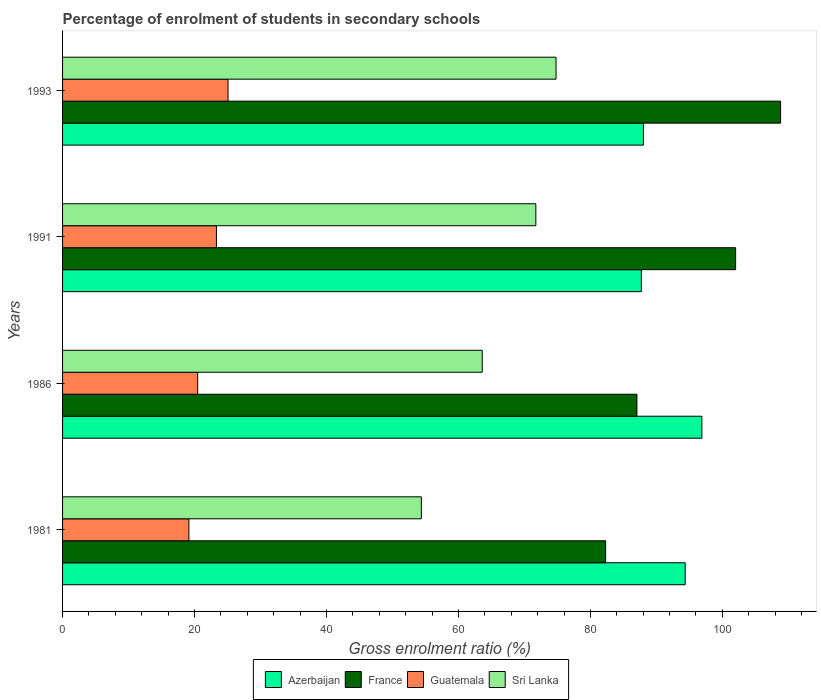Are the number of bars per tick equal to the number of legend labels?
Your answer should be compact. Yes. Are the number of bars on each tick of the Y-axis equal?
Keep it short and to the point. Yes. How many bars are there on the 1st tick from the bottom?
Keep it short and to the point. 4. In how many cases, is the number of bars for a given year not equal to the number of legend labels?
Your answer should be compact. 0. What is the percentage of students enrolled in secondary schools in Guatemala in 1986?
Provide a short and direct response. 20.48. Across all years, what is the maximum percentage of students enrolled in secondary schools in Azerbaijan?
Provide a succinct answer. 96.89. Across all years, what is the minimum percentage of students enrolled in secondary schools in France?
Provide a succinct answer. 82.31. In which year was the percentage of students enrolled in secondary schools in Azerbaijan maximum?
Offer a terse response. 1986. What is the total percentage of students enrolled in secondary schools in Sri Lanka in the graph?
Your answer should be compact. 264.51. What is the difference between the percentage of students enrolled in secondary schools in Azerbaijan in 1981 and that in 1993?
Ensure brevity in your answer.  6.33. What is the difference between the percentage of students enrolled in secondary schools in France in 1981 and the percentage of students enrolled in secondary schools in Sri Lanka in 1993?
Your answer should be compact. 7.51. What is the average percentage of students enrolled in secondary schools in Sri Lanka per year?
Keep it short and to the point. 66.13. In the year 1981, what is the difference between the percentage of students enrolled in secondary schools in Guatemala and percentage of students enrolled in secondary schools in Azerbaijan?
Offer a very short reply. -75.22. In how many years, is the percentage of students enrolled in secondary schools in France greater than 36 %?
Keep it short and to the point. 4. What is the ratio of the percentage of students enrolled in secondary schools in France in 1991 to that in 1993?
Provide a succinct answer. 0.94. What is the difference between the highest and the second highest percentage of students enrolled in secondary schools in Azerbaijan?
Your answer should be very brief. 2.53. What is the difference between the highest and the lowest percentage of students enrolled in secondary schools in Guatemala?
Make the answer very short. 5.93. In how many years, is the percentage of students enrolled in secondary schools in Sri Lanka greater than the average percentage of students enrolled in secondary schools in Sri Lanka taken over all years?
Your answer should be very brief. 2. Is the sum of the percentage of students enrolled in secondary schools in France in 1981 and 1993 greater than the maximum percentage of students enrolled in secondary schools in Guatemala across all years?
Give a very brief answer. Yes. What does the 4th bar from the top in 1981 represents?
Keep it short and to the point. Azerbaijan. What does the 4th bar from the bottom in 1993 represents?
Make the answer very short. Sri Lanka. Is it the case that in every year, the sum of the percentage of students enrolled in secondary schools in Guatemala and percentage of students enrolled in secondary schools in Azerbaijan is greater than the percentage of students enrolled in secondary schools in France?
Make the answer very short. Yes. How many bars are there?
Your answer should be compact. 16. What is the difference between two consecutive major ticks on the X-axis?
Ensure brevity in your answer.  20. Are the values on the major ticks of X-axis written in scientific E-notation?
Offer a very short reply. No. Where does the legend appear in the graph?
Offer a very short reply. Bottom center. How are the legend labels stacked?
Offer a terse response. Horizontal. What is the title of the graph?
Offer a terse response. Percentage of enrolment of students in secondary schools. Does "Central Europe" appear as one of the legend labels in the graph?
Offer a very short reply. No. What is the label or title of the X-axis?
Ensure brevity in your answer.  Gross enrolment ratio (%). What is the label or title of the Y-axis?
Offer a terse response. Years. What is the Gross enrolment ratio (%) of Azerbaijan in 1981?
Provide a succinct answer. 94.37. What is the Gross enrolment ratio (%) in France in 1981?
Provide a short and direct response. 82.31. What is the Gross enrolment ratio (%) of Guatemala in 1981?
Your response must be concise. 19.15. What is the Gross enrolment ratio (%) in Sri Lanka in 1981?
Your answer should be compact. 54.38. What is the Gross enrolment ratio (%) of Azerbaijan in 1986?
Provide a succinct answer. 96.89. What is the Gross enrolment ratio (%) of France in 1986?
Offer a very short reply. 87.05. What is the Gross enrolment ratio (%) of Guatemala in 1986?
Give a very brief answer. 20.48. What is the Gross enrolment ratio (%) in Sri Lanka in 1986?
Offer a very short reply. 63.61. What is the Gross enrolment ratio (%) in Azerbaijan in 1991?
Offer a terse response. 87.72. What is the Gross enrolment ratio (%) of France in 1991?
Ensure brevity in your answer.  102.01. What is the Gross enrolment ratio (%) of Guatemala in 1991?
Ensure brevity in your answer.  23.32. What is the Gross enrolment ratio (%) in Sri Lanka in 1991?
Your answer should be very brief. 71.73. What is the Gross enrolment ratio (%) of Azerbaijan in 1993?
Provide a short and direct response. 88.04. What is the Gross enrolment ratio (%) of France in 1993?
Provide a short and direct response. 108.82. What is the Gross enrolment ratio (%) in Guatemala in 1993?
Your response must be concise. 25.08. What is the Gross enrolment ratio (%) in Sri Lanka in 1993?
Your answer should be very brief. 74.79. Across all years, what is the maximum Gross enrolment ratio (%) of Azerbaijan?
Ensure brevity in your answer.  96.89. Across all years, what is the maximum Gross enrolment ratio (%) of France?
Your response must be concise. 108.82. Across all years, what is the maximum Gross enrolment ratio (%) of Guatemala?
Offer a very short reply. 25.08. Across all years, what is the maximum Gross enrolment ratio (%) of Sri Lanka?
Ensure brevity in your answer.  74.79. Across all years, what is the minimum Gross enrolment ratio (%) of Azerbaijan?
Make the answer very short. 87.72. Across all years, what is the minimum Gross enrolment ratio (%) in France?
Your answer should be compact. 82.31. Across all years, what is the minimum Gross enrolment ratio (%) in Guatemala?
Provide a short and direct response. 19.15. Across all years, what is the minimum Gross enrolment ratio (%) in Sri Lanka?
Give a very brief answer. 54.38. What is the total Gross enrolment ratio (%) of Azerbaijan in the graph?
Offer a terse response. 367.01. What is the total Gross enrolment ratio (%) in France in the graph?
Your answer should be compact. 380.19. What is the total Gross enrolment ratio (%) in Guatemala in the graph?
Ensure brevity in your answer.  88.02. What is the total Gross enrolment ratio (%) in Sri Lanka in the graph?
Provide a short and direct response. 264.51. What is the difference between the Gross enrolment ratio (%) of Azerbaijan in 1981 and that in 1986?
Give a very brief answer. -2.53. What is the difference between the Gross enrolment ratio (%) in France in 1981 and that in 1986?
Offer a very short reply. -4.74. What is the difference between the Gross enrolment ratio (%) in Guatemala in 1981 and that in 1986?
Offer a very short reply. -1.33. What is the difference between the Gross enrolment ratio (%) of Sri Lanka in 1981 and that in 1986?
Provide a succinct answer. -9.23. What is the difference between the Gross enrolment ratio (%) of Azerbaijan in 1981 and that in 1991?
Your response must be concise. 6.65. What is the difference between the Gross enrolment ratio (%) of France in 1981 and that in 1991?
Ensure brevity in your answer.  -19.7. What is the difference between the Gross enrolment ratio (%) of Guatemala in 1981 and that in 1991?
Your response must be concise. -4.17. What is the difference between the Gross enrolment ratio (%) in Sri Lanka in 1981 and that in 1991?
Make the answer very short. -17.35. What is the difference between the Gross enrolment ratio (%) in Azerbaijan in 1981 and that in 1993?
Make the answer very short. 6.33. What is the difference between the Gross enrolment ratio (%) of France in 1981 and that in 1993?
Keep it short and to the point. -26.52. What is the difference between the Gross enrolment ratio (%) in Guatemala in 1981 and that in 1993?
Offer a terse response. -5.93. What is the difference between the Gross enrolment ratio (%) of Sri Lanka in 1981 and that in 1993?
Your answer should be very brief. -20.42. What is the difference between the Gross enrolment ratio (%) in Azerbaijan in 1986 and that in 1991?
Keep it short and to the point. 9.17. What is the difference between the Gross enrolment ratio (%) of France in 1986 and that in 1991?
Your answer should be very brief. -14.96. What is the difference between the Gross enrolment ratio (%) of Guatemala in 1986 and that in 1991?
Provide a succinct answer. -2.84. What is the difference between the Gross enrolment ratio (%) in Sri Lanka in 1986 and that in 1991?
Give a very brief answer. -8.12. What is the difference between the Gross enrolment ratio (%) in Azerbaijan in 1986 and that in 1993?
Your response must be concise. 8.86. What is the difference between the Gross enrolment ratio (%) of France in 1986 and that in 1993?
Offer a terse response. -21.77. What is the difference between the Gross enrolment ratio (%) in Guatemala in 1986 and that in 1993?
Keep it short and to the point. -4.6. What is the difference between the Gross enrolment ratio (%) of Sri Lanka in 1986 and that in 1993?
Provide a short and direct response. -11.19. What is the difference between the Gross enrolment ratio (%) of Azerbaijan in 1991 and that in 1993?
Your answer should be very brief. -0.32. What is the difference between the Gross enrolment ratio (%) in France in 1991 and that in 1993?
Provide a succinct answer. -6.82. What is the difference between the Gross enrolment ratio (%) of Guatemala in 1991 and that in 1993?
Your answer should be very brief. -1.76. What is the difference between the Gross enrolment ratio (%) in Sri Lanka in 1991 and that in 1993?
Keep it short and to the point. -3.06. What is the difference between the Gross enrolment ratio (%) in Azerbaijan in 1981 and the Gross enrolment ratio (%) in France in 1986?
Ensure brevity in your answer.  7.31. What is the difference between the Gross enrolment ratio (%) in Azerbaijan in 1981 and the Gross enrolment ratio (%) in Guatemala in 1986?
Offer a terse response. 73.89. What is the difference between the Gross enrolment ratio (%) in Azerbaijan in 1981 and the Gross enrolment ratio (%) in Sri Lanka in 1986?
Keep it short and to the point. 30.76. What is the difference between the Gross enrolment ratio (%) of France in 1981 and the Gross enrolment ratio (%) of Guatemala in 1986?
Keep it short and to the point. 61.83. What is the difference between the Gross enrolment ratio (%) in France in 1981 and the Gross enrolment ratio (%) in Sri Lanka in 1986?
Your answer should be very brief. 18.7. What is the difference between the Gross enrolment ratio (%) in Guatemala in 1981 and the Gross enrolment ratio (%) in Sri Lanka in 1986?
Make the answer very short. -44.46. What is the difference between the Gross enrolment ratio (%) of Azerbaijan in 1981 and the Gross enrolment ratio (%) of France in 1991?
Make the answer very short. -7.64. What is the difference between the Gross enrolment ratio (%) in Azerbaijan in 1981 and the Gross enrolment ratio (%) in Guatemala in 1991?
Your answer should be compact. 71.04. What is the difference between the Gross enrolment ratio (%) in Azerbaijan in 1981 and the Gross enrolment ratio (%) in Sri Lanka in 1991?
Provide a short and direct response. 22.64. What is the difference between the Gross enrolment ratio (%) of France in 1981 and the Gross enrolment ratio (%) of Guatemala in 1991?
Your answer should be very brief. 58.99. What is the difference between the Gross enrolment ratio (%) in France in 1981 and the Gross enrolment ratio (%) in Sri Lanka in 1991?
Make the answer very short. 10.58. What is the difference between the Gross enrolment ratio (%) of Guatemala in 1981 and the Gross enrolment ratio (%) of Sri Lanka in 1991?
Make the answer very short. -52.58. What is the difference between the Gross enrolment ratio (%) of Azerbaijan in 1981 and the Gross enrolment ratio (%) of France in 1993?
Offer a very short reply. -14.46. What is the difference between the Gross enrolment ratio (%) of Azerbaijan in 1981 and the Gross enrolment ratio (%) of Guatemala in 1993?
Offer a very short reply. 69.29. What is the difference between the Gross enrolment ratio (%) of Azerbaijan in 1981 and the Gross enrolment ratio (%) of Sri Lanka in 1993?
Offer a terse response. 19.57. What is the difference between the Gross enrolment ratio (%) in France in 1981 and the Gross enrolment ratio (%) in Guatemala in 1993?
Provide a succinct answer. 57.23. What is the difference between the Gross enrolment ratio (%) in France in 1981 and the Gross enrolment ratio (%) in Sri Lanka in 1993?
Make the answer very short. 7.51. What is the difference between the Gross enrolment ratio (%) in Guatemala in 1981 and the Gross enrolment ratio (%) in Sri Lanka in 1993?
Offer a very short reply. -55.65. What is the difference between the Gross enrolment ratio (%) in Azerbaijan in 1986 and the Gross enrolment ratio (%) in France in 1991?
Your answer should be very brief. -5.12. What is the difference between the Gross enrolment ratio (%) in Azerbaijan in 1986 and the Gross enrolment ratio (%) in Guatemala in 1991?
Offer a very short reply. 73.57. What is the difference between the Gross enrolment ratio (%) in Azerbaijan in 1986 and the Gross enrolment ratio (%) in Sri Lanka in 1991?
Offer a very short reply. 25.16. What is the difference between the Gross enrolment ratio (%) of France in 1986 and the Gross enrolment ratio (%) of Guatemala in 1991?
Make the answer very short. 63.73. What is the difference between the Gross enrolment ratio (%) of France in 1986 and the Gross enrolment ratio (%) of Sri Lanka in 1991?
Make the answer very short. 15.32. What is the difference between the Gross enrolment ratio (%) in Guatemala in 1986 and the Gross enrolment ratio (%) in Sri Lanka in 1991?
Give a very brief answer. -51.25. What is the difference between the Gross enrolment ratio (%) in Azerbaijan in 1986 and the Gross enrolment ratio (%) in France in 1993?
Give a very brief answer. -11.93. What is the difference between the Gross enrolment ratio (%) of Azerbaijan in 1986 and the Gross enrolment ratio (%) of Guatemala in 1993?
Your response must be concise. 71.82. What is the difference between the Gross enrolment ratio (%) in Azerbaijan in 1986 and the Gross enrolment ratio (%) in Sri Lanka in 1993?
Offer a very short reply. 22.1. What is the difference between the Gross enrolment ratio (%) of France in 1986 and the Gross enrolment ratio (%) of Guatemala in 1993?
Your answer should be compact. 61.97. What is the difference between the Gross enrolment ratio (%) of France in 1986 and the Gross enrolment ratio (%) of Sri Lanka in 1993?
Provide a succinct answer. 12.26. What is the difference between the Gross enrolment ratio (%) in Guatemala in 1986 and the Gross enrolment ratio (%) in Sri Lanka in 1993?
Make the answer very short. -54.32. What is the difference between the Gross enrolment ratio (%) in Azerbaijan in 1991 and the Gross enrolment ratio (%) in France in 1993?
Give a very brief answer. -21.1. What is the difference between the Gross enrolment ratio (%) in Azerbaijan in 1991 and the Gross enrolment ratio (%) in Guatemala in 1993?
Give a very brief answer. 62.64. What is the difference between the Gross enrolment ratio (%) of Azerbaijan in 1991 and the Gross enrolment ratio (%) of Sri Lanka in 1993?
Ensure brevity in your answer.  12.93. What is the difference between the Gross enrolment ratio (%) in France in 1991 and the Gross enrolment ratio (%) in Guatemala in 1993?
Your answer should be very brief. 76.93. What is the difference between the Gross enrolment ratio (%) of France in 1991 and the Gross enrolment ratio (%) of Sri Lanka in 1993?
Provide a succinct answer. 27.21. What is the difference between the Gross enrolment ratio (%) of Guatemala in 1991 and the Gross enrolment ratio (%) of Sri Lanka in 1993?
Ensure brevity in your answer.  -51.47. What is the average Gross enrolment ratio (%) in Azerbaijan per year?
Offer a very short reply. 91.75. What is the average Gross enrolment ratio (%) of France per year?
Your answer should be very brief. 95.05. What is the average Gross enrolment ratio (%) of Guatemala per year?
Give a very brief answer. 22.01. What is the average Gross enrolment ratio (%) of Sri Lanka per year?
Offer a very short reply. 66.13. In the year 1981, what is the difference between the Gross enrolment ratio (%) in Azerbaijan and Gross enrolment ratio (%) in France?
Your answer should be compact. 12.06. In the year 1981, what is the difference between the Gross enrolment ratio (%) of Azerbaijan and Gross enrolment ratio (%) of Guatemala?
Give a very brief answer. 75.22. In the year 1981, what is the difference between the Gross enrolment ratio (%) in Azerbaijan and Gross enrolment ratio (%) in Sri Lanka?
Make the answer very short. 39.99. In the year 1981, what is the difference between the Gross enrolment ratio (%) of France and Gross enrolment ratio (%) of Guatemala?
Give a very brief answer. 63.16. In the year 1981, what is the difference between the Gross enrolment ratio (%) in France and Gross enrolment ratio (%) in Sri Lanka?
Your answer should be very brief. 27.93. In the year 1981, what is the difference between the Gross enrolment ratio (%) of Guatemala and Gross enrolment ratio (%) of Sri Lanka?
Offer a terse response. -35.23. In the year 1986, what is the difference between the Gross enrolment ratio (%) in Azerbaijan and Gross enrolment ratio (%) in France?
Offer a terse response. 9.84. In the year 1986, what is the difference between the Gross enrolment ratio (%) in Azerbaijan and Gross enrolment ratio (%) in Guatemala?
Make the answer very short. 76.42. In the year 1986, what is the difference between the Gross enrolment ratio (%) in Azerbaijan and Gross enrolment ratio (%) in Sri Lanka?
Offer a very short reply. 33.29. In the year 1986, what is the difference between the Gross enrolment ratio (%) in France and Gross enrolment ratio (%) in Guatemala?
Provide a short and direct response. 66.57. In the year 1986, what is the difference between the Gross enrolment ratio (%) of France and Gross enrolment ratio (%) of Sri Lanka?
Provide a succinct answer. 23.44. In the year 1986, what is the difference between the Gross enrolment ratio (%) in Guatemala and Gross enrolment ratio (%) in Sri Lanka?
Provide a short and direct response. -43.13. In the year 1991, what is the difference between the Gross enrolment ratio (%) in Azerbaijan and Gross enrolment ratio (%) in France?
Your answer should be compact. -14.29. In the year 1991, what is the difference between the Gross enrolment ratio (%) in Azerbaijan and Gross enrolment ratio (%) in Guatemala?
Give a very brief answer. 64.4. In the year 1991, what is the difference between the Gross enrolment ratio (%) in Azerbaijan and Gross enrolment ratio (%) in Sri Lanka?
Ensure brevity in your answer.  15.99. In the year 1991, what is the difference between the Gross enrolment ratio (%) in France and Gross enrolment ratio (%) in Guatemala?
Keep it short and to the point. 78.69. In the year 1991, what is the difference between the Gross enrolment ratio (%) in France and Gross enrolment ratio (%) in Sri Lanka?
Your answer should be very brief. 30.28. In the year 1991, what is the difference between the Gross enrolment ratio (%) in Guatemala and Gross enrolment ratio (%) in Sri Lanka?
Provide a succinct answer. -48.41. In the year 1993, what is the difference between the Gross enrolment ratio (%) in Azerbaijan and Gross enrolment ratio (%) in France?
Provide a succinct answer. -20.79. In the year 1993, what is the difference between the Gross enrolment ratio (%) of Azerbaijan and Gross enrolment ratio (%) of Guatemala?
Make the answer very short. 62.96. In the year 1993, what is the difference between the Gross enrolment ratio (%) in Azerbaijan and Gross enrolment ratio (%) in Sri Lanka?
Make the answer very short. 13.24. In the year 1993, what is the difference between the Gross enrolment ratio (%) of France and Gross enrolment ratio (%) of Guatemala?
Give a very brief answer. 83.75. In the year 1993, what is the difference between the Gross enrolment ratio (%) of France and Gross enrolment ratio (%) of Sri Lanka?
Offer a terse response. 34.03. In the year 1993, what is the difference between the Gross enrolment ratio (%) of Guatemala and Gross enrolment ratio (%) of Sri Lanka?
Your response must be concise. -49.72. What is the ratio of the Gross enrolment ratio (%) in Azerbaijan in 1981 to that in 1986?
Ensure brevity in your answer.  0.97. What is the ratio of the Gross enrolment ratio (%) of France in 1981 to that in 1986?
Offer a very short reply. 0.95. What is the ratio of the Gross enrolment ratio (%) in Guatemala in 1981 to that in 1986?
Ensure brevity in your answer.  0.94. What is the ratio of the Gross enrolment ratio (%) in Sri Lanka in 1981 to that in 1986?
Make the answer very short. 0.85. What is the ratio of the Gross enrolment ratio (%) in Azerbaijan in 1981 to that in 1991?
Your response must be concise. 1.08. What is the ratio of the Gross enrolment ratio (%) of France in 1981 to that in 1991?
Provide a short and direct response. 0.81. What is the ratio of the Gross enrolment ratio (%) of Guatemala in 1981 to that in 1991?
Your answer should be very brief. 0.82. What is the ratio of the Gross enrolment ratio (%) of Sri Lanka in 1981 to that in 1991?
Ensure brevity in your answer.  0.76. What is the ratio of the Gross enrolment ratio (%) of Azerbaijan in 1981 to that in 1993?
Offer a very short reply. 1.07. What is the ratio of the Gross enrolment ratio (%) of France in 1981 to that in 1993?
Give a very brief answer. 0.76. What is the ratio of the Gross enrolment ratio (%) in Guatemala in 1981 to that in 1993?
Give a very brief answer. 0.76. What is the ratio of the Gross enrolment ratio (%) in Sri Lanka in 1981 to that in 1993?
Your answer should be compact. 0.73. What is the ratio of the Gross enrolment ratio (%) of Azerbaijan in 1986 to that in 1991?
Your answer should be compact. 1.1. What is the ratio of the Gross enrolment ratio (%) in France in 1986 to that in 1991?
Your answer should be very brief. 0.85. What is the ratio of the Gross enrolment ratio (%) of Guatemala in 1986 to that in 1991?
Offer a very short reply. 0.88. What is the ratio of the Gross enrolment ratio (%) of Sri Lanka in 1986 to that in 1991?
Your answer should be compact. 0.89. What is the ratio of the Gross enrolment ratio (%) in Azerbaijan in 1986 to that in 1993?
Your answer should be compact. 1.1. What is the ratio of the Gross enrolment ratio (%) of France in 1986 to that in 1993?
Your answer should be very brief. 0.8. What is the ratio of the Gross enrolment ratio (%) in Guatemala in 1986 to that in 1993?
Provide a succinct answer. 0.82. What is the ratio of the Gross enrolment ratio (%) of Sri Lanka in 1986 to that in 1993?
Your answer should be compact. 0.85. What is the ratio of the Gross enrolment ratio (%) of Azerbaijan in 1991 to that in 1993?
Keep it short and to the point. 1. What is the ratio of the Gross enrolment ratio (%) in France in 1991 to that in 1993?
Provide a short and direct response. 0.94. What is the difference between the highest and the second highest Gross enrolment ratio (%) of Azerbaijan?
Your answer should be very brief. 2.53. What is the difference between the highest and the second highest Gross enrolment ratio (%) of France?
Your answer should be compact. 6.82. What is the difference between the highest and the second highest Gross enrolment ratio (%) in Guatemala?
Make the answer very short. 1.76. What is the difference between the highest and the second highest Gross enrolment ratio (%) of Sri Lanka?
Ensure brevity in your answer.  3.06. What is the difference between the highest and the lowest Gross enrolment ratio (%) of Azerbaijan?
Offer a very short reply. 9.17. What is the difference between the highest and the lowest Gross enrolment ratio (%) of France?
Ensure brevity in your answer.  26.52. What is the difference between the highest and the lowest Gross enrolment ratio (%) of Guatemala?
Provide a succinct answer. 5.93. What is the difference between the highest and the lowest Gross enrolment ratio (%) in Sri Lanka?
Your response must be concise. 20.42. 